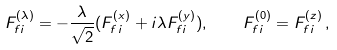<formula> <loc_0><loc_0><loc_500><loc_500>F _ { f i } ^ { ( \lambda ) } = - \frac { \lambda } { \sqrt { 2 } } ( F _ { f i } ^ { ( x ) } + i \lambda F _ { f i } ^ { ( y ) } ) , \quad F _ { f i } ^ { ( 0 ) } = F _ { f i } ^ { ( z ) } \, ,</formula> 